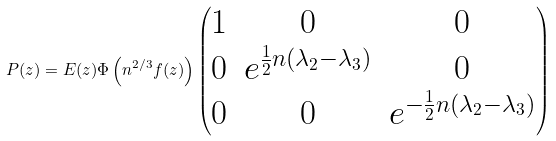Convert formula to latex. <formula><loc_0><loc_0><loc_500><loc_500>P ( z ) = E ( z ) \Phi \left ( n ^ { 2 / 3 } f ( z ) \right ) \begin{pmatrix} 1 & 0 & 0 \\ 0 & e ^ { \frac { 1 } { 2 } n ( \lambda _ { 2 } - \lambda _ { 3 } ) } & 0 \\ 0 & 0 & e ^ { - \frac { 1 } { 2 } n ( \lambda _ { 2 } - \lambda _ { 3 } ) } \end{pmatrix}</formula> 